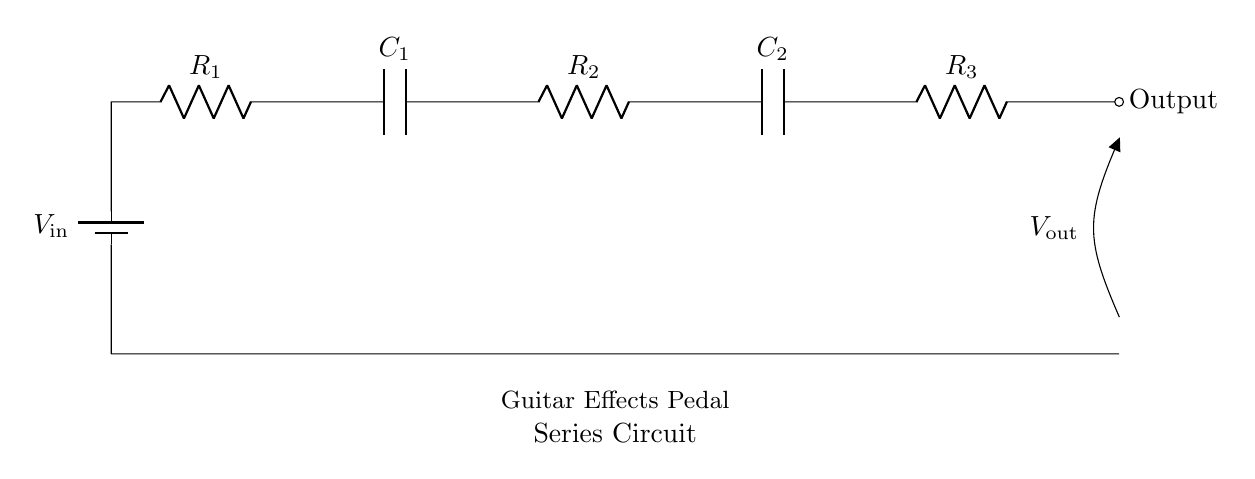What is the voltage source in this circuit? The voltage source in the circuit is labeled as \( V_\text{in} \) and is represented by a battery symbol.
Answer: V_in What are the components in this series circuit? The components listed in the circuit are resistors \( R_1, R_2, R_3 \) and capacitors \( C_1, C_2 \), all arranged in a series configuration.
Answer: Resistors and capacitors How many resistors are present in the circuit? By counting the labels in the circuit diagram, there are three resistors: \( R_1, R_2, R_3 \).
Answer: Three What is the output measurement taken from? The output measurement, denoted as \( V_\text{out} \), is taken at the last component in the series and is also marked by an open terminal leading to output.
Answer: The last component What happens to the overall resistance in a series circuit when components are added? In a series circuit, the overall resistance increases because the total resistance is the sum of all individual resistors in series.
Answer: It increases What is the effect of adding capacitors in series on total capacitance? In a series circuit, when capacitors are added, the total capacitance decreases, since the reciprocal of the total capacitance is the sum of the reciprocals of individual capacitances.
Answer: It decreases 